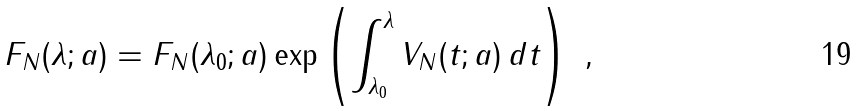<formula> <loc_0><loc_0><loc_500><loc_500>F _ { N } ( \lambda ; a ) = F _ { N } ( \lambda _ { 0 } ; a ) \exp \left ( \int _ { \lambda _ { 0 } } ^ { \lambda } V _ { N } ( t ; a ) \, d t \right ) \ ,</formula> 